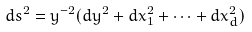Convert formula to latex. <formula><loc_0><loc_0><loc_500><loc_500>d s ^ { 2 } = y ^ { - 2 } ( d y ^ { 2 } + d x _ { 1 } ^ { 2 } + \cdots + d x _ { d } ^ { 2 } )</formula> 